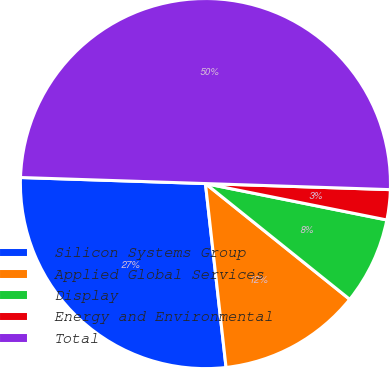Convert chart. <chart><loc_0><loc_0><loc_500><loc_500><pie_chart><fcel>Silicon Systems Group<fcel>Applied Global Services<fcel>Display<fcel>Energy and Environmental<fcel>Total<nl><fcel>27.3%<fcel>12.46%<fcel>7.61%<fcel>2.63%<fcel>50.0%<nl></chart> 